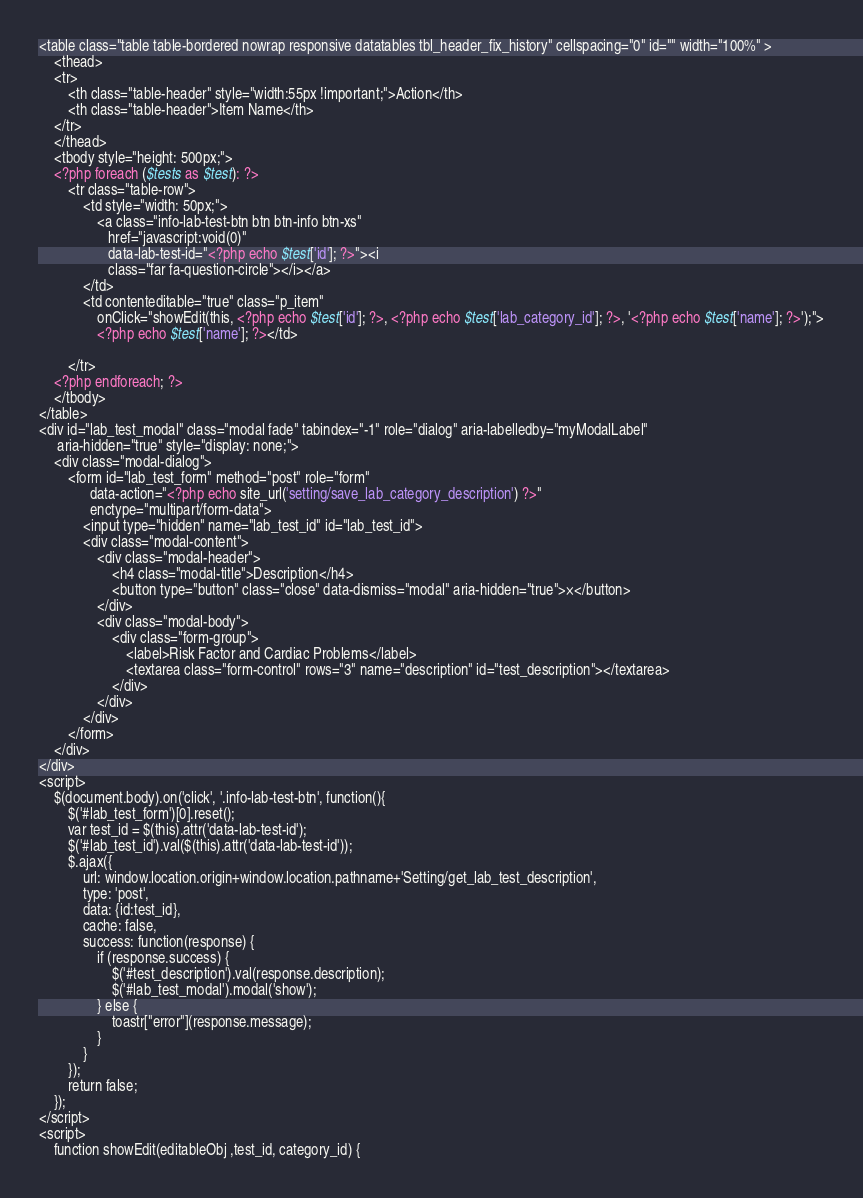Convert code to text. <code><loc_0><loc_0><loc_500><loc_500><_PHP_><table class="table table-bordered nowrap responsive datatables tbl_header_fix_history" cellspacing="0" id="" width="100%" >
    <thead>
    <tr>
        <th class="table-header" style="width:55px !important;">Action</th>
        <th class="table-header">Item Name</th>
    </tr>
    </thead>
    <tbody style="height: 500px;">
    <?php foreach ($tests as $test): ?>
        <tr class="table-row">
            <td style="width: 50px;">
                <a class="info-lab-test-btn btn btn-info btn-xs"
                   href="javascript:void(0)"
                   data-lab-test-id="<?php echo $test['id']; ?>"><i
                   class="far fa-question-circle"></i></a>
            </td>
            <td contenteditable="true" class="p_item"
                onClick="showEdit(this, <?php echo $test['id']; ?>, <?php echo $test['lab_category_id']; ?>, '<?php echo $test['name']; ?>');">
                <?php echo $test['name']; ?></td>

        </tr>
    <?php endforeach; ?>
    </tbody>
</table>
<div id="lab_test_modal" class="modal fade" tabindex="-1" role="dialog" aria-labelledby="myModalLabel"
     aria-hidden="true" style="display: none;">
    <div class="modal-dialog">
        <form id="lab_test_form" method="post" role="form"
              data-action="<?php echo site_url('setting/save_lab_category_description') ?>"
              enctype="multipart/form-data">
            <input type="hidden" name="lab_test_id" id="lab_test_id">
            <div class="modal-content">
                <div class="modal-header">
                    <h4 class="modal-title">Description</h4>
                    <button type="button" class="close" data-dismiss="modal" aria-hidden="true">×</button>
                </div>
                <div class="modal-body">
                    <div class="form-group">
                        <label>Risk Factor and Cardiac Problems</label>
                        <textarea class="form-control" rows="3" name="description" id="test_description"></textarea>
                    </div>
                </div>
            </div>
        </form>
    </div>
</div>
<script>
    $(document.body).on('click', '.info-lab-test-btn', function(){
        $('#lab_test_form')[0].reset();
        var test_id = $(this).attr('data-lab-test-id');
        $('#lab_test_id').val($(this).attr('data-lab-test-id'));
        $.ajax({
            url: window.location.origin+window.location.pathname+'Setting/get_lab_test_description',
            type: 'post',
            data: {id:test_id},
            cache: false,
            success: function(response) {
                if (response.success) {
                    $('#test_description').val(response.description);
                    $('#lab_test_modal').modal('show');
                } else {
                    toastr["error"](response.message);
                }
            }
        });
        return false;
    });
</script>
<script>
    function showEdit(editableObj ,test_id, category_id) {</code> 